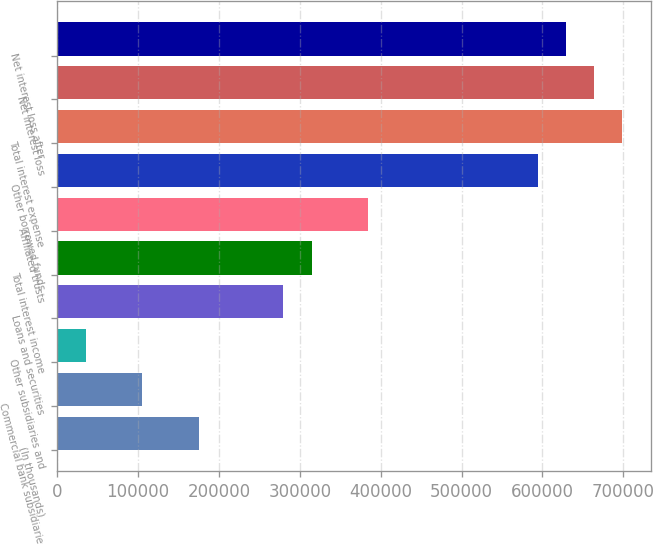<chart> <loc_0><loc_0><loc_500><loc_500><bar_chart><fcel>(In thousands)<fcel>Commercial bank subsidiaries<fcel>Other subsidiaries and<fcel>Loans and securities<fcel>Total interest income<fcel>Affiliated trusts<fcel>Other borrowed funds<fcel>Total interest expense<fcel>Net interest loss<fcel>Net interest loss after<nl><fcel>174801<fcel>104915<fcel>35029<fcel>279630<fcel>314573<fcel>384459<fcel>594117<fcel>698946<fcel>664003<fcel>629060<nl></chart> 